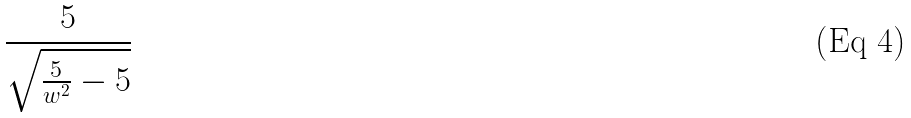<formula> <loc_0><loc_0><loc_500><loc_500>\frac { 5 } { \sqrt { \frac { 5 } { w ^ { 2 } } - 5 } }</formula> 